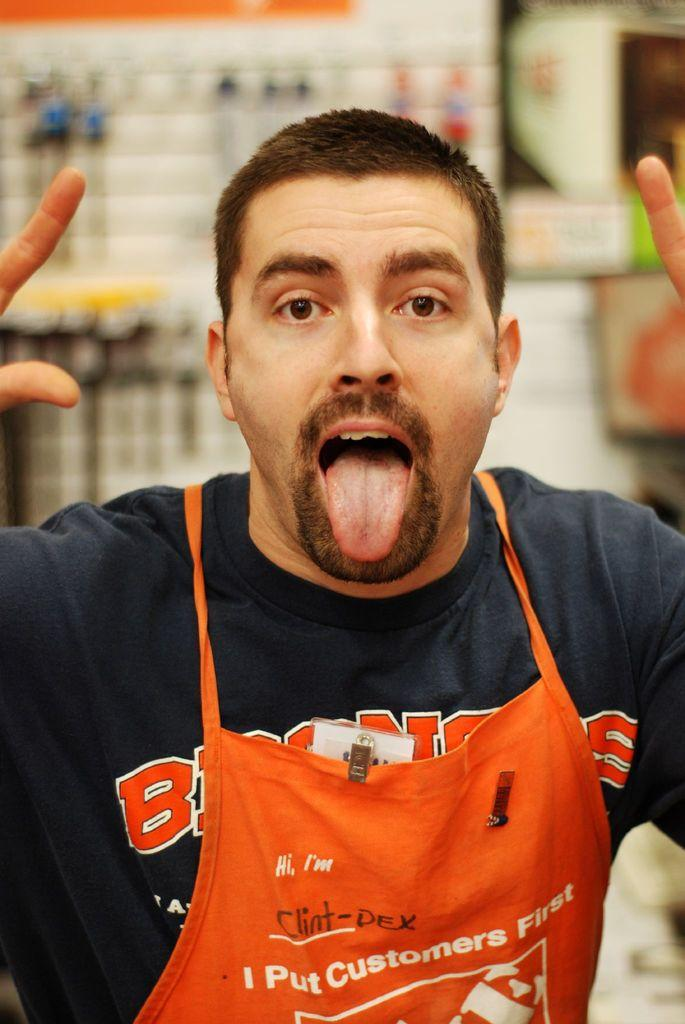<image>
Write a terse but informative summary of the picture. A Home Depo employee with an apron on that puts customers first. 